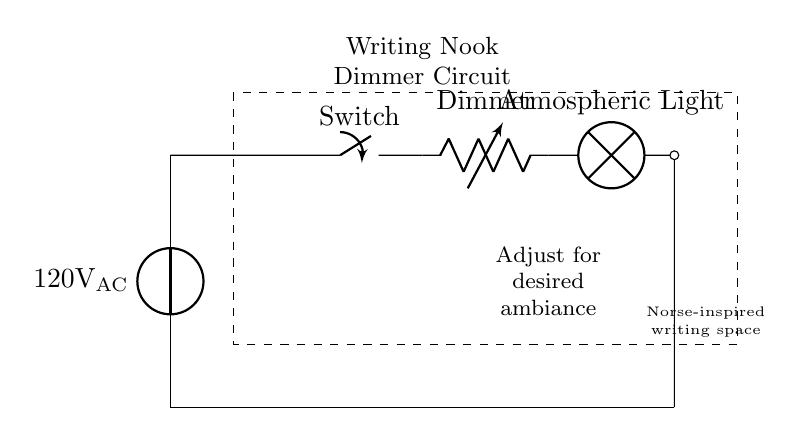What is the source voltage in this circuit? The circuit shows a voltage source labeled as 120 volts AC, which indicates the potential difference provided to the circuit components.
Answer: 120 volts AC What type of switch is used in this circuit? The circuit diagram specifies a component labeled as "Switch" which is a manual switch used to turn the circuit on or off, typical in household appliance circuits.
Answer: Switch What component allows for ambient lighting adjustment? The circuit includes a variable resistor labeled as "Dimmer," designed to control the brightness of the light bulb based on its resistance, thus creating atmospheric lighting.
Answer: Dimmer How does the dimmer affect the light bulb? The dimmer adjusts the amount of current passing through to the light bulb by varying its resistance; less current results in a dimmer light, while more current creates a brighter light.
Answer: By varying current What connects the light bulb and the power source? The circuit is a simple series connection where the wire leads run directly from the power source through the switch, the dimmer, and finally to the light bulb, completing the loop.
Answer: Series connection What type of lamp is used in this circuit? The circuit indicates a "lamp" component labeled as "Atmospheric Light," suggesting it is designed specifically for creating a warm and inviting ambiance in the designated writing nook.
Answer: Atmospheric Light 